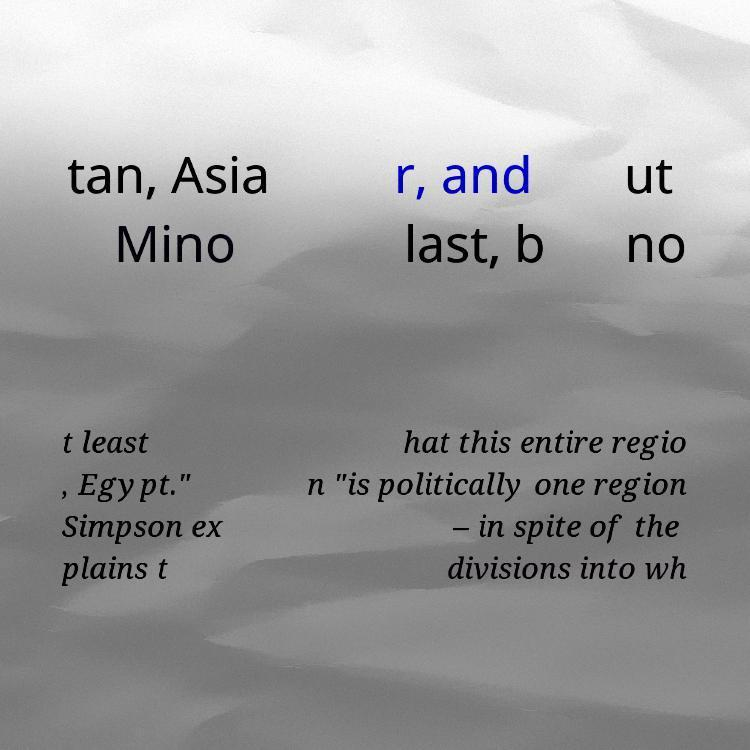Can you read and provide the text displayed in the image?This photo seems to have some interesting text. Can you extract and type it out for me? tan, Asia Mino r, and last, b ut no t least , Egypt." Simpson ex plains t hat this entire regio n "is politically one region – in spite of the divisions into wh 